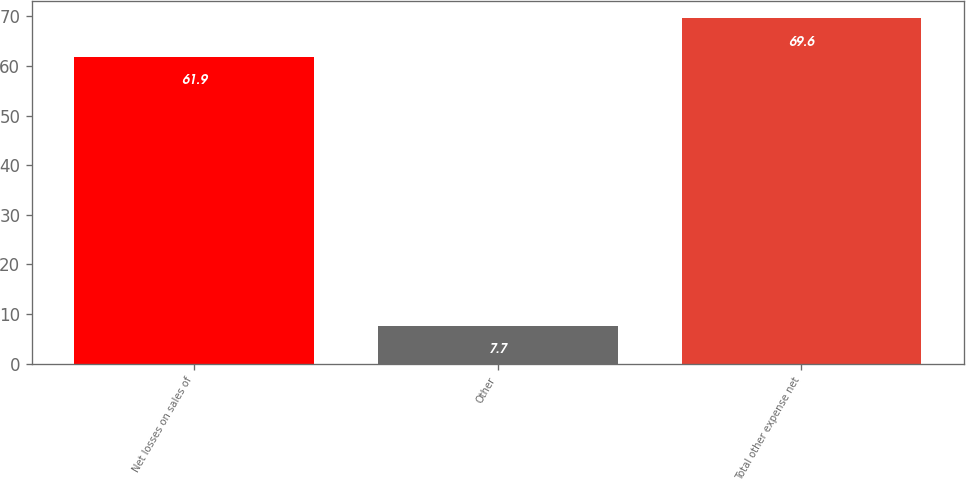Convert chart to OTSL. <chart><loc_0><loc_0><loc_500><loc_500><bar_chart><fcel>Net losses on sales of<fcel>Other<fcel>Total other expense net<nl><fcel>61.9<fcel>7.7<fcel>69.6<nl></chart> 